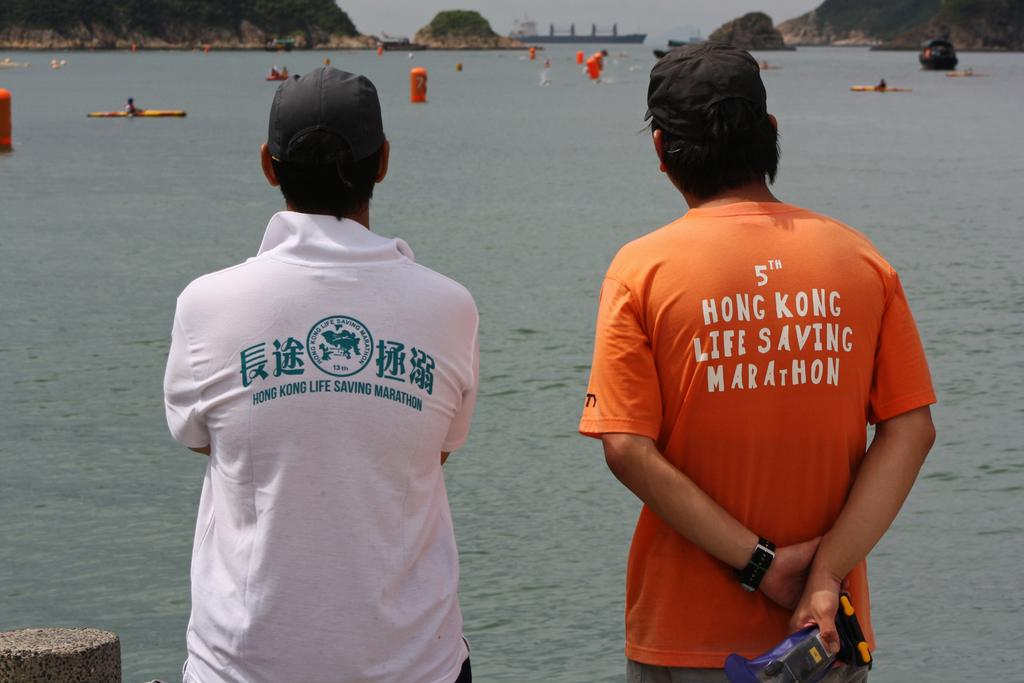How many people are present in the image? There are two persons standing in the image. What is visible in the image besides the people? Water, boats, and mountains are visible in the image. Can you describe the background of the image? There are mountains in the background of the image. What type of wine is being served at the dinner in the image? There is no dinner or wine present in the image; it features two people standing near water with boats and mountains in the background. 